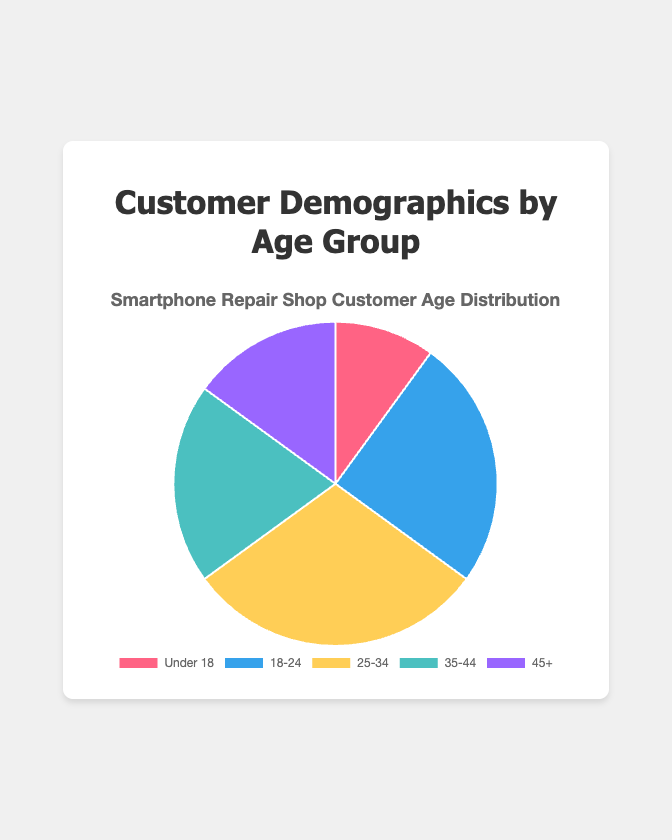What percentage of customers are aged 25-34? The data shows the percentage of customers in the age group 25-34 is 30%.
Answer: 30% Which two age groups together make up half of the customer base? 18-24 makes up 25% and 25-34 makes up 30%. Combined, they make up 25% + 30% = 55%. This is more than half. However, combining 25-34 (30%) with 35-44 (20%) results in 30% + 20% = 50%.
Answer: 25-34 and 35-44 How does the percentage of customers aged 35-44 compare to those aged 45+? The percentage for 35-44 is 20%, and for 45+ is 15%. Therefore, 35-44 has a higher percentage by 5%.
Answer: 35-44 has 5% more What proportion of the total customer base is under 18? The data shows that 10% of the customers are under 18 years old.
Answer: 10% Which age group has the highest representation and what's its percentage? 25-34 has the highest representation, accounting for 30% of the total.
Answer: 25-34 at 30% What is the total percentage of customers who are either under 18 or over 45? Under 18 is 10% and over 45 is 15%. Together, they account for 10% + 15% = 25%.
Answer: 25% What color represents the 18-24 age group? Based on the visual attributes, the color representing the 18-24 age group is blue.
Answer: Blue Is the percentage of customers aged 18-24 more or less than double the percentage of customers aged under 18? The percentage of customers aged 18-24 is 25%, and double the under 18 percentage (10%) is 20%. Since 25% is more than 20%, it is more.
Answer: More What are the approximate proportions of the categories represented by warm colors (red and yellow)? Which age groups do they encapsulate? The warm colors (red and yellow) represent Under 18 and 25-34. Under 18 accounts for 10%, and 25-34 accounts for 30%. The total proportion is 10% + 30% = 40%.
Answer: 40% for Under 18 and 25-34 What is the average percentage for the age groups represented in the pie chart? The age groups have percentages: 10, 25, 30, 20, and 15. The sum is 10 + 25 + 30 + 20 + 15 = 100. The average is 100 / 5 = 20%.
Answer: 20% 